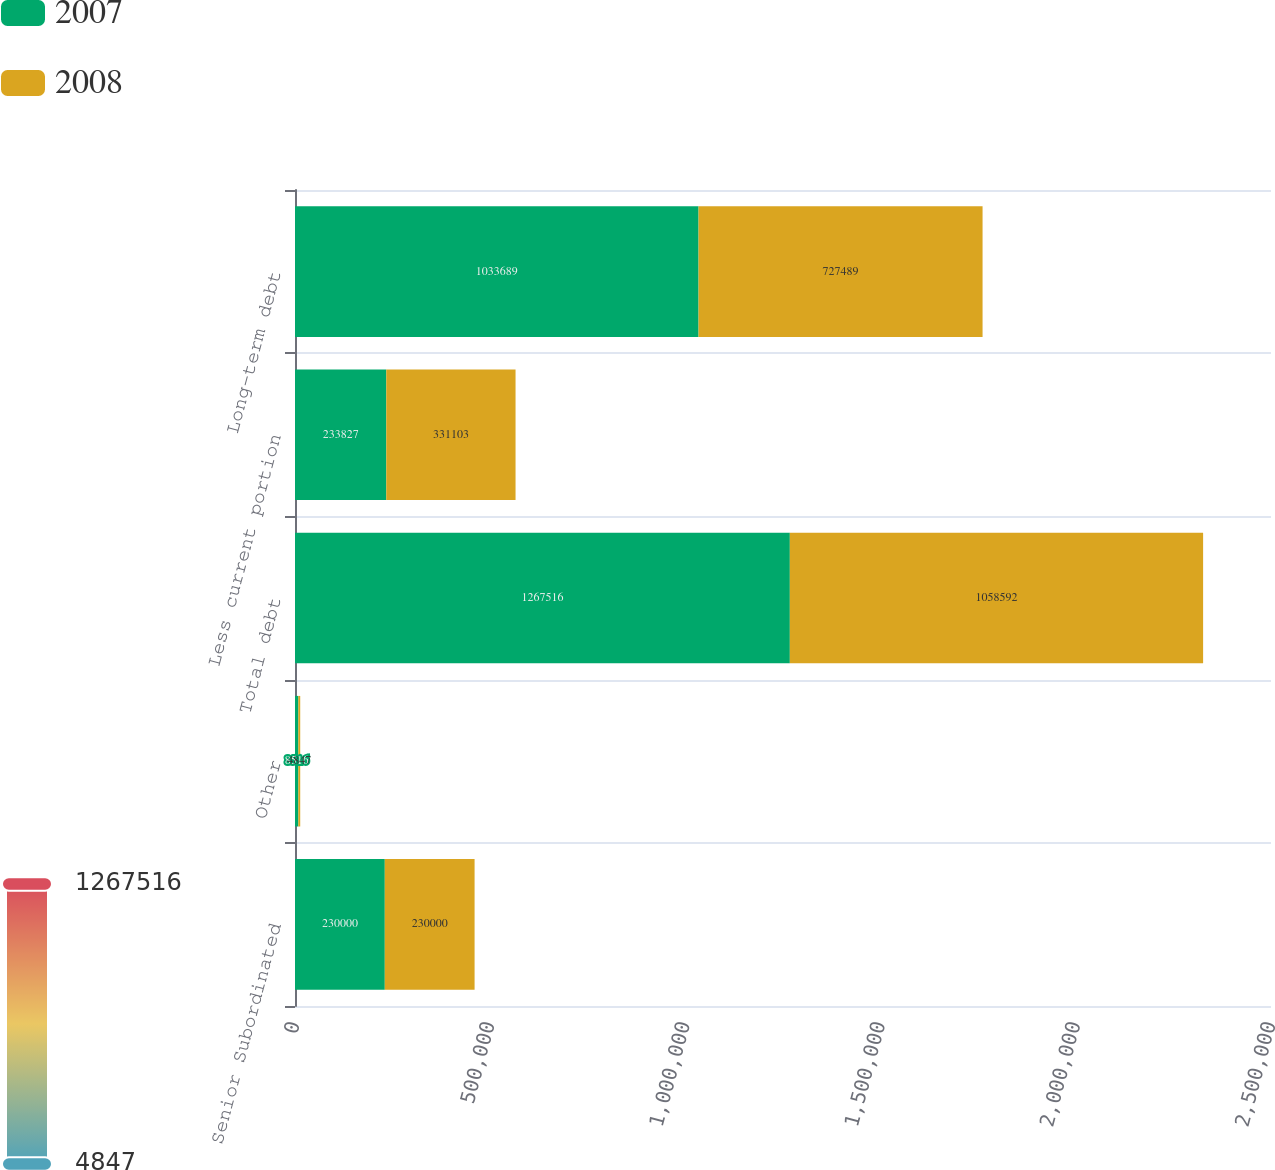Convert chart. <chart><loc_0><loc_0><loc_500><loc_500><stacked_bar_chart><ecel><fcel>Senior Subordinated<fcel>Other<fcel>Total debt<fcel>Less current portion<fcel>Long-term debt<nl><fcel>2007<fcel>230000<fcel>8516<fcel>1.26752e+06<fcel>233827<fcel>1.03369e+06<nl><fcel>2008<fcel>230000<fcel>4847<fcel>1.05859e+06<fcel>331103<fcel>727489<nl></chart> 